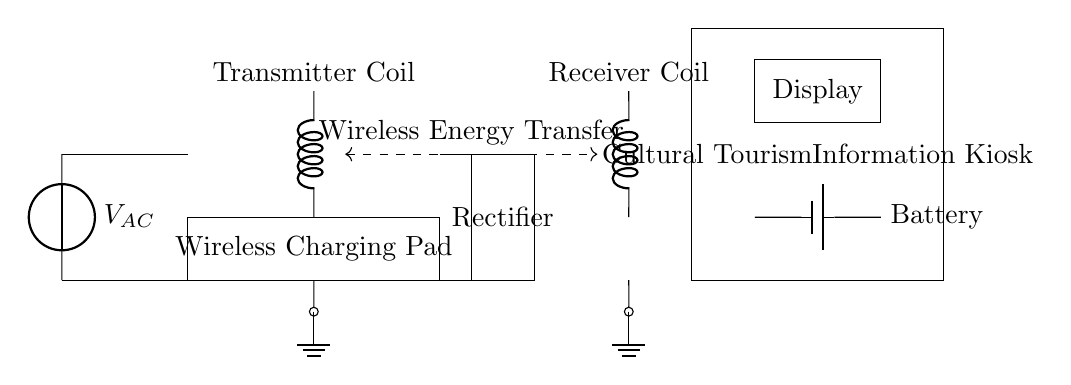What components are present in this circuit? The circuit contains a wireless charging pad, transmitter coil, rectifier, receiver coil, battery, and display in the information kiosk.
Answer: wireless charging pad, transmitter coil, rectifier, receiver coil, battery, display What is the purpose of the transmitter coil? The transmitter coil is part of the wireless charging system and is responsible for creating a magnetic field to facilitate energy transfer to the receiver coil.
Answer: to create a magnetic field What type of energy transfer is depicted in the circuit? The circuit shows wireless energy transfer, indicated by the dashed line connecting the transmitter coil and receiver coil, allowing energy to be transferred without direct electrical connections.
Answer: wireless energy transfer How many batteries are shown in the circuit? There is one battery in the circuit, which is located within the cultural tourism information kiosk. The diagram shows the battery symbol labeled "Battery."
Answer: one battery What is the role of the rectifier in this circuit? The rectifier converts the alternating current generated by the AC source into direct current, which is required to charge the battery and power the display in the information kiosk.
Answer: converts AC to DC Which component in the circuit is responsible for displaying information? The display is responsible for showing information to users of the cultural tourism kiosk. It is indicated by the rectangular shape labeled "Display" in the circuit.
Answer: display What kind of power source is shown for this circuit? The power source shown is an AC source, which is indicated on the circuit diagram with "V AC." It provides alternating current to the wireless charging system.
Answer: AC source 